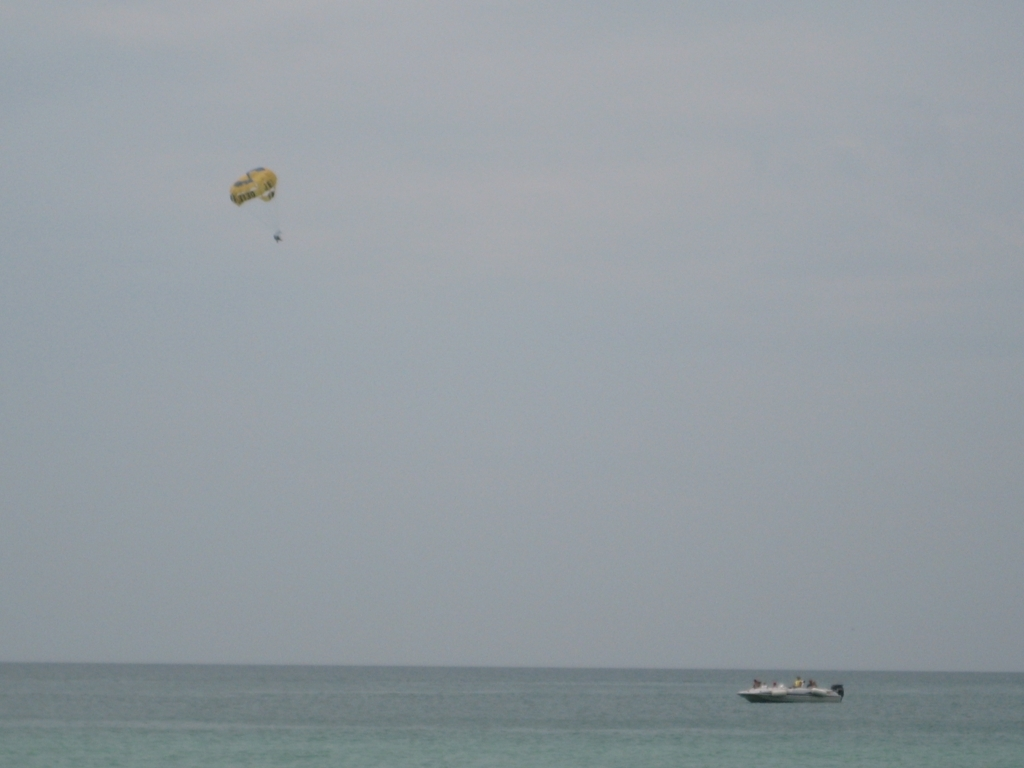Can you describe what activities are being depicted in this image? Certainly! The image captures a leisure activity where an individual is parasailing, tethered to a canopy that resembles a parachute. This individual is being pulled by a motorboat, which is also visible in the picture, over what seems to be a calm sea. The sky is overcast, giving a serene, yet somewhat monotonous look to the scene. 